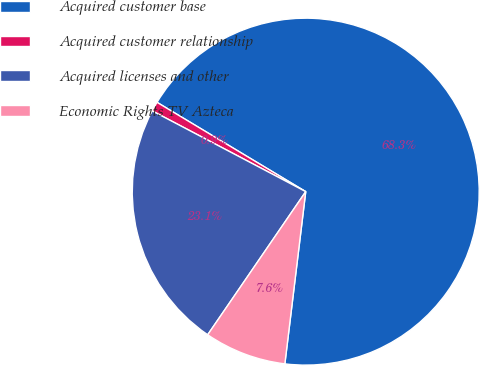Convert chart to OTSL. <chart><loc_0><loc_0><loc_500><loc_500><pie_chart><fcel>Acquired customer base<fcel>Acquired customer relationship<fcel>Acquired licenses and other<fcel>Economic Rights TV Azteca<nl><fcel>68.31%<fcel>0.9%<fcel>23.15%<fcel>7.64%<nl></chart> 